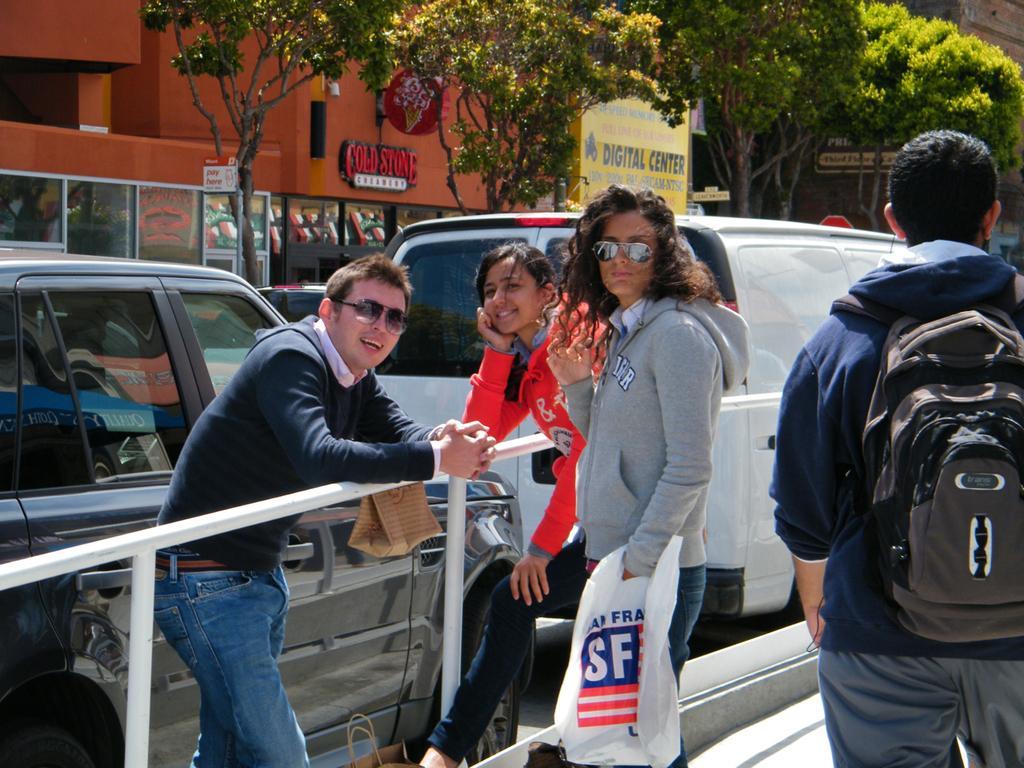Please provide a concise description of this image. In this image we can see some people standing on the ground. One person is carrying a bag, we can also see a railing, some vehicles parked on the ground, groups of buildings with glass doors, trees and signboards with some text. At the bottom of the image we can see a bag. 